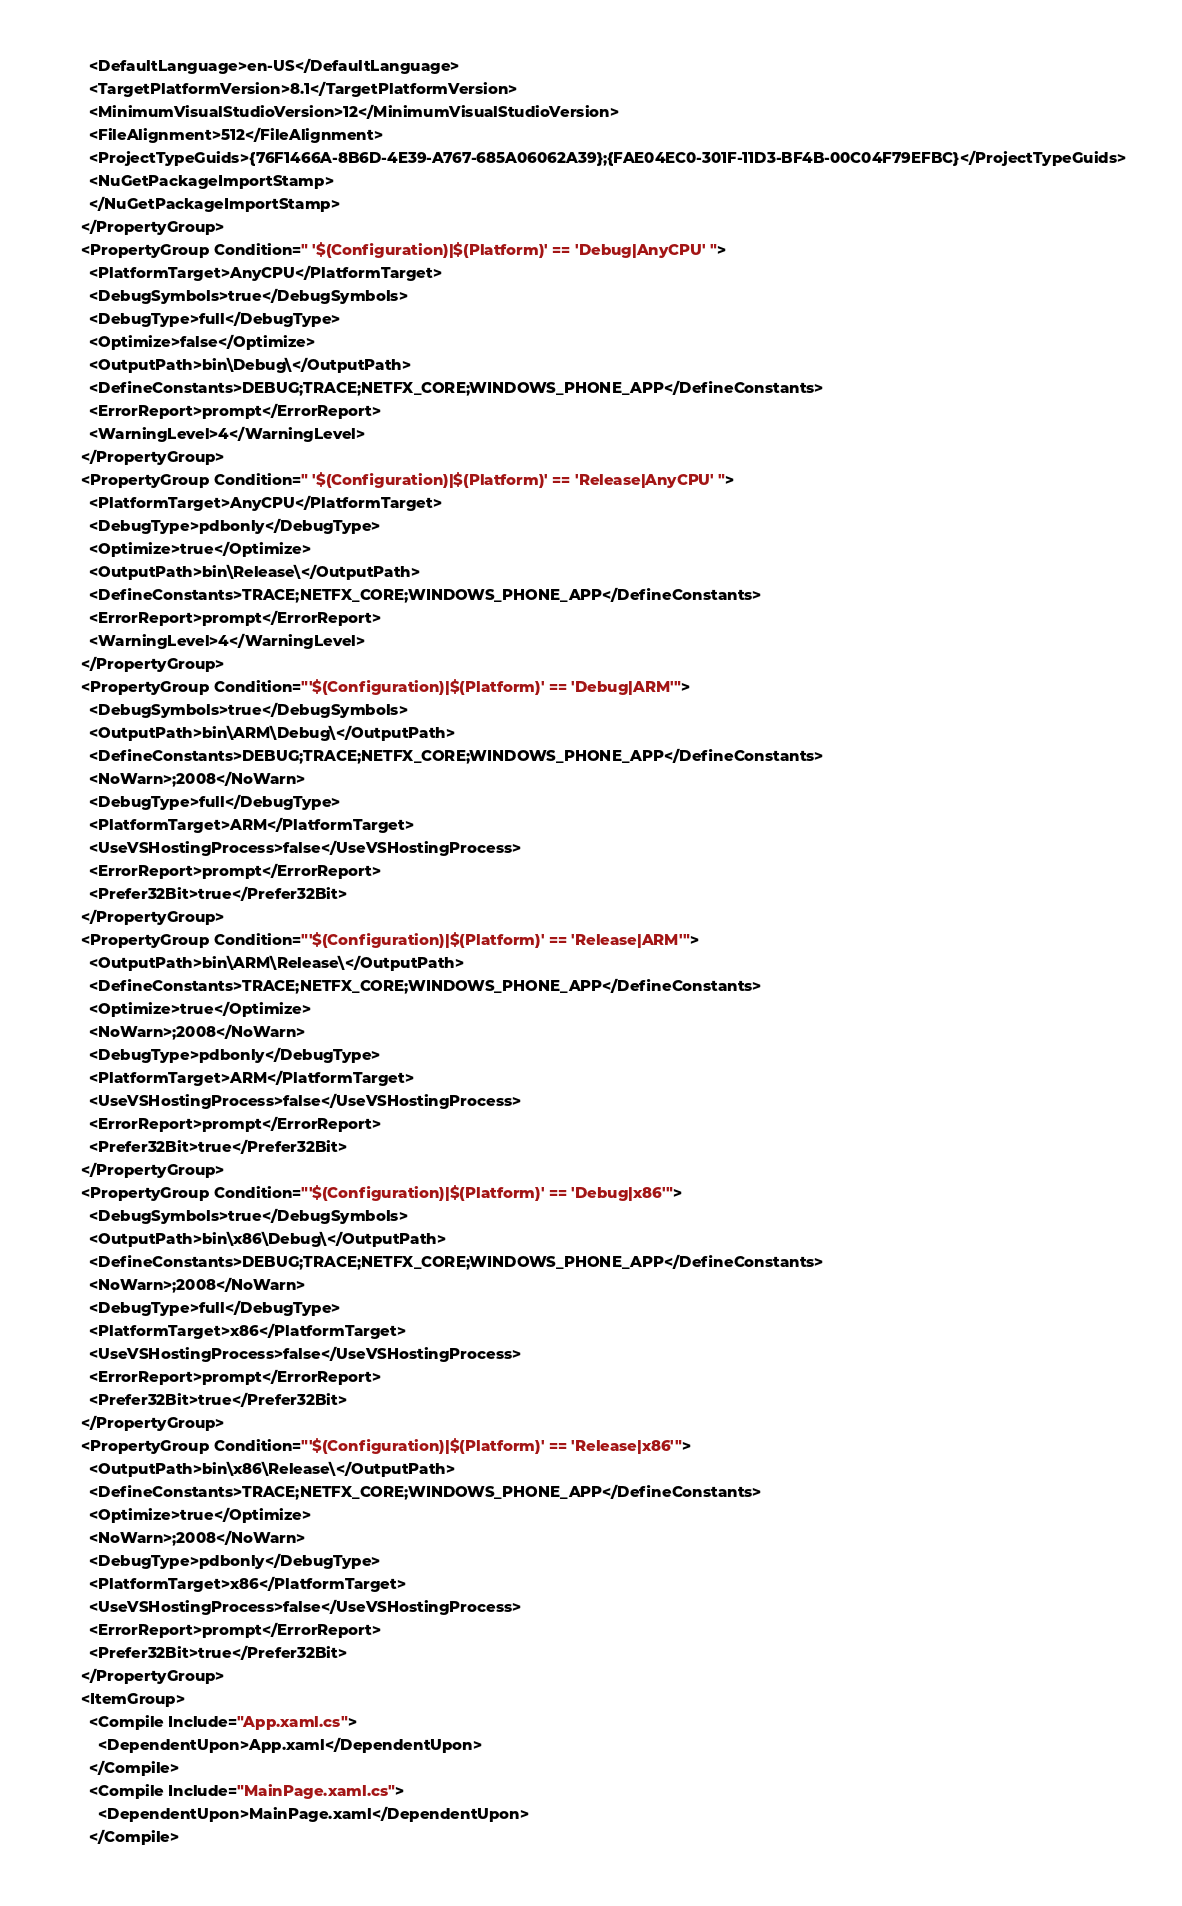<code> <loc_0><loc_0><loc_500><loc_500><_XML_>    <DefaultLanguage>en-US</DefaultLanguage>
    <TargetPlatformVersion>8.1</TargetPlatformVersion>
    <MinimumVisualStudioVersion>12</MinimumVisualStudioVersion>
    <FileAlignment>512</FileAlignment>
    <ProjectTypeGuids>{76F1466A-8B6D-4E39-A767-685A06062A39};{FAE04EC0-301F-11D3-BF4B-00C04F79EFBC}</ProjectTypeGuids>
    <NuGetPackageImportStamp>
    </NuGetPackageImportStamp>
  </PropertyGroup>
  <PropertyGroup Condition=" '$(Configuration)|$(Platform)' == 'Debug|AnyCPU' ">
    <PlatformTarget>AnyCPU</PlatformTarget>
    <DebugSymbols>true</DebugSymbols>
    <DebugType>full</DebugType>
    <Optimize>false</Optimize>
    <OutputPath>bin\Debug\</OutputPath>
    <DefineConstants>DEBUG;TRACE;NETFX_CORE;WINDOWS_PHONE_APP</DefineConstants>
    <ErrorReport>prompt</ErrorReport>
    <WarningLevel>4</WarningLevel>
  </PropertyGroup>
  <PropertyGroup Condition=" '$(Configuration)|$(Platform)' == 'Release|AnyCPU' ">
    <PlatformTarget>AnyCPU</PlatformTarget>
    <DebugType>pdbonly</DebugType>
    <Optimize>true</Optimize>
    <OutputPath>bin\Release\</OutputPath>
    <DefineConstants>TRACE;NETFX_CORE;WINDOWS_PHONE_APP</DefineConstants>
    <ErrorReport>prompt</ErrorReport>
    <WarningLevel>4</WarningLevel>
  </PropertyGroup>
  <PropertyGroup Condition="'$(Configuration)|$(Platform)' == 'Debug|ARM'">
    <DebugSymbols>true</DebugSymbols>
    <OutputPath>bin\ARM\Debug\</OutputPath>
    <DefineConstants>DEBUG;TRACE;NETFX_CORE;WINDOWS_PHONE_APP</DefineConstants>
    <NoWarn>;2008</NoWarn>
    <DebugType>full</DebugType>
    <PlatformTarget>ARM</PlatformTarget>
    <UseVSHostingProcess>false</UseVSHostingProcess>
    <ErrorReport>prompt</ErrorReport>
    <Prefer32Bit>true</Prefer32Bit>
  </PropertyGroup>
  <PropertyGroup Condition="'$(Configuration)|$(Platform)' == 'Release|ARM'">
    <OutputPath>bin\ARM\Release\</OutputPath>
    <DefineConstants>TRACE;NETFX_CORE;WINDOWS_PHONE_APP</DefineConstants>
    <Optimize>true</Optimize>
    <NoWarn>;2008</NoWarn>
    <DebugType>pdbonly</DebugType>
    <PlatformTarget>ARM</PlatformTarget>
    <UseVSHostingProcess>false</UseVSHostingProcess>
    <ErrorReport>prompt</ErrorReport>
    <Prefer32Bit>true</Prefer32Bit>
  </PropertyGroup>
  <PropertyGroup Condition="'$(Configuration)|$(Platform)' == 'Debug|x86'">
    <DebugSymbols>true</DebugSymbols>
    <OutputPath>bin\x86\Debug\</OutputPath>
    <DefineConstants>DEBUG;TRACE;NETFX_CORE;WINDOWS_PHONE_APP</DefineConstants>
    <NoWarn>;2008</NoWarn>
    <DebugType>full</DebugType>
    <PlatformTarget>x86</PlatformTarget>
    <UseVSHostingProcess>false</UseVSHostingProcess>
    <ErrorReport>prompt</ErrorReport>
    <Prefer32Bit>true</Prefer32Bit>
  </PropertyGroup>
  <PropertyGroup Condition="'$(Configuration)|$(Platform)' == 'Release|x86'">
    <OutputPath>bin\x86\Release\</OutputPath>
    <DefineConstants>TRACE;NETFX_CORE;WINDOWS_PHONE_APP</DefineConstants>
    <Optimize>true</Optimize>
    <NoWarn>;2008</NoWarn>
    <DebugType>pdbonly</DebugType>
    <PlatformTarget>x86</PlatformTarget>
    <UseVSHostingProcess>false</UseVSHostingProcess>
    <ErrorReport>prompt</ErrorReport>
    <Prefer32Bit>true</Prefer32Bit>
  </PropertyGroup>
  <ItemGroup>
    <Compile Include="App.xaml.cs">
      <DependentUpon>App.xaml</DependentUpon>
    </Compile>
    <Compile Include="MainPage.xaml.cs">
      <DependentUpon>MainPage.xaml</DependentUpon>
    </Compile></code> 